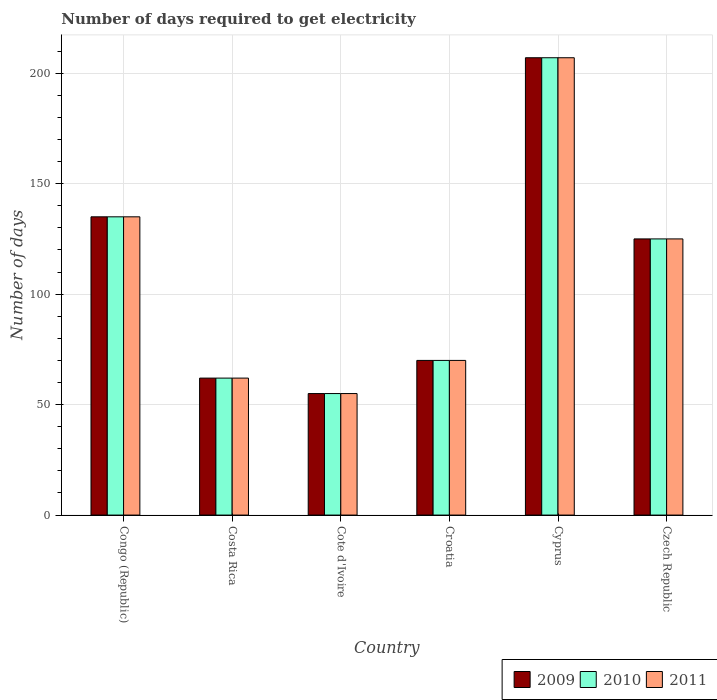Are the number of bars per tick equal to the number of legend labels?
Provide a succinct answer. Yes. Are the number of bars on each tick of the X-axis equal?
Keep it short and to the point. Yes. How many bars are there on the 1st tick from the right?
Provide a succinct answer. 3. What is the label of the 5th group of bars from the left?
Your answer should be very brief. Cyprus. In how many cases, is the number of bars for a given country not equal to the number of legend labels?
Keep it short and to the point. 0. Across all countries, what is the maximum number of days required to get electricity in in 2009?
Provide a succinct answer. 207. Across all countries, what is the minimum number of days required to get electricity in in 2009?
Your answer should be compact. 55. In which country was the number of days required to get electricity in in 2009 maximum?
Provide a succinct answer. Cyprus. In which country was the number of days required to get electricity in in 2010 minimum?
Make the answer very short. Cote d'Ivoire. What is the total number of days required to get electricity in in 2009 in the graph?
Provide a succinct answer. 654. What is the difference between the number of days required to get electricity in in 2011 in Cote d'Ivoire and that in Cyprus?
Your answer should be compact. -152. What is the difference between the number of days required to get electricity in in 2010 in Costa Rica and the number of days required to get electricity in in 2009 in Cyprus?
Offer a terse response. -145. What is the average number of days required to get electricity in in 2010 per country?
Your answer should be very brief. 109. What is the difference between the number of days required to get electricity in of/in 2011 and number of days required to get electricity in of/in 2010 in Croatia?
Provide a succinct answer. 0. In how many countries, is the number of days required to get electricity in in 2010 greater than 140 days?
Your answer should be very brief. 1. What is the ratio of the number of days required to get electricity in in 2009 in Costa Rica to that in Cyprus?
Your answer should be compact. 0.3. What is the difference between the highest and the lowest number of days required to get electricity in in 2011?
Offer a very short reply. 152. Is the sum of the number of days required to get electricity in in 2011 in Costa Rica and Cote d'Ivoire greater than the maximum number of days required to get electricity in in 2010 across all countries?
Give a very brief answer. No. Are all the bars in the graph horizontal?
Offer a terse response. No. Are the values on the major ticks of Y-axis written in scientific E-notation?
Provide a succinct answer. No. Does the graph contain grids?
Ensure brevity in your answer.  Yes. How many legend labels are there?
Your response must be concise. 3. How are the legend labels stacked?
Give a very brief answer. Horizontal. What is the title of the graph?
Give a very brief answer. Number of days required to get electricity. What is the label or title of the X-axis?
Provide a short and direct response. Country. What is the label or title of the Y-axis?
Give a very brief answer. Number of days. What is the Number of days of 2009 in Congo (Republic)?
Your answer should be very brief. 135. What is the Number of days in 2010 in Congo (Republic)?
Ensure brevity in your answer.  135. What is the Number of days of 2011 in Congo (Republic)?
Make the answer very short. 135. What is the Number of days of 2009 in Costa Rica?
Your response must be concise. 62. What is the Number of days in 2009 in Croatia?
Offer a terse response. 70. What is the Number of days of 2010 in Croatia?
Your answer should be compact. 70. What is the Number of days of 2009 in Cyprus?
Your answer should be compact. 207. What is the Number of days of 2010 in Cyprus?
Your response must be concise. 207. What is the Number of days in 2011 in Cyprus?
Provide a succinct answer. 207. What is the Number of days in 2009 in Czech Republic?
Your answer should be compact. 125. What is the Number of days of 2010 in Czech Republic?
Provide a succinct answer. 125. What is the Number of days of 2011 in Czech Republic?
Offer a terse response. 125. Across all countries, what is the maximum Number of days of 2009?
Your response must be concise. 207. Across all countries, what is the maximum Number of days in 2010?
Your answer should be very brief. 207. Across all countries, what is the maximum Number of days in 2011?
Your answer should be very brief. 207. Across all countries, what is the minimum Number of days of 2009?
Make the answer very short. 55. Across all countries, what is the minimum Number of days of 2010?
Make the answer very short. 55. Across all countries, what is the minimum Number of days of 2011?
Provide a succinct answer. 55. What is the total Number of days in 2009 in the graph?
Provide a succinct answer. 654. What is the total Number of days of 2010 in the graph?
Ensure brevity in your answer.  654. What is the total Number of days of 2011 in the graph?
Provide a short and direct response. 654. What is the difference between the Number of days of 2010 in Congo (Republic) and that in Costa Rica?
Offer a terse response. 73. What is the difference between the Number of days in 2011 in Congo (Republic) and that in Cote d'Ivoire?
Make the answer very short. 80. What is the difference between the Number of days of 2009 in Congo (Republic) and that in Croatia?
Give a very brief answer. 65. What is the difference between the Number of days of 2011 in Congo (Republic) and that in Croatia?
Make the answer very short. 65. What is the difference between the Number of days in 2009 in Congo (Republic) and that in Cyprus?
Give a very brief answer. -72. What is the difference between the Number of days of 2010 in Congo (Republic) and that in Cyprus?
Provide a short and direct response. -72. What is the difference between the Number of days in 2011 in Congo (Republic) and that in Cyprus?
Provide a short and direct response. -72. What is the difference between the Number of days in 2010 in Costa Rica and that in Cote d'Ivoire?
Your answer should be compact. 7. What is the difference between the Number of days in 2011 in Costa Rica and that in Cote d'Ivoire?
Provide a short and direct response. 7. What is the difference between the Number of days of 2009 in Costa Rica and that in Croatia?
Keep it short and to the point. -8. What is the difference between the Number of days in 2011 in Costa Rica and that in Croatia?
Your response must be concise. -8. What is the difference between the Number of days in 2009 in Costa Rica and that in Cyprus?
Keep it short and to the point. -145. What is the difference between the Number of days of 2010 in Costa Rica and that in Cyprus?
Give a very brief answer. -145. What is the difference between the Number of days in 2011 in Costa Rica and that in Cyprus?
Offer a terse response. -145. What is the difference between the Number of days of 2009 in Costa Rica and that in Czech Republic?
Give a very brief answer. -63. What is the difference between the Number of days in 2010 in Costa Rica and that in Czech Republic?
Keep it short and to the point. -63. What is the difference between the Number of days in 2011 in Costa Rica and that in Czech Republic?
Your response must be concise. -63. What is the difference between the Number of days of 2010 in Cote d'Ivoire and that in Croatia?
Ensure brevity in your answer.  -15. What is the difference between the Number of days in 2009 in Cote d'Ivoire and that in Cyprus?
Keep it short and to the point. -152. What is the difference between the Number of days in 2010 in Cote d'Ivoire and that in Cyprus?
Your answer should be compact. -152. What is the difference between the Number of days of 2011 in Cote d'Ivoire and that in Cyprus?
Offer a terse response. -152. What is the difference between the Number of days in 2009 in Cote d'Ivoire and that in Czech Republic?
Make the answer very short. -70. What is the difference between the Number of days of 2010 in Cote d'Ivoire and that in Czech Republic?
Provide a succinct answer. -70. What is the difference between the Number of days in 2011 in Cote d'Ivoire and that in Czech Republic?
Give a very brief answer. -70. What is the difference between the Number of days in 2009 in Croatia and that in Cyprus?
Provide a short and direct response. -137. What is the difference between the Number of days in 2010 in Croatia and that in Cyprus?
Keep it short and to the point. -137. What is the difference between the Number of days in 2011 in Croatia and that in Cyprus?
Your answer should be very brief. -137. What is the difference between the Number of days of 2009 in Croatia and that in Czech Republic?
Your response must be concise. -55. What is the difference between the Number of days of 2010 in Croatia and that in Czech Republic?
Offer a very short reply. -55. What is the difference between the Number of days of 2011 in Croatia and that in Czech Republic?
Offer a very short reply. -55. What is the difference between the Number of days of 2009 in Cyprus and that in Czech Republic?
Your response must be concise. 82. What is the difference between the Number of days in 2010 in Cyprus and that in Czech Republic?
Provide a short and direct response. 82. What is the difference between the Number of days in 2010 in Congo (Republic) and the Number of days in 2011 in Costa Rica?
Your response must be concise. 73. What is the difference between the Number of days in 2009 in Congo (Republic) and the Number of days in 2010 in Cote d'Ivoire?
Offer a very short reply. 80. What is the difference between the Number of days of 2009 in Congo (Republic) and the Number of days of 2011 in Cote d'Ivoire?
Your answer should be compact. 80. What is the difference between the Number of days in 2010 in Congo (Republic) and the Number of days in 2011 in Cote d'Ivoire?
Your answer should be compact. 80. What is the difference between the Number of days in 2009 in Congo (Republic) and the Number of days in 2011 in Croatia?
Your response must be concise. 65. What is the difference between the Number of days in 2009 in Congo (Republic) and the Number of days in 2010 in Cyprus?
Your answer should be very brief. -72. What is the difference between the Number of days in 2009 in Congo (Republic) and the Number of days in 2011 in Cyprus?
Make the answer very short. -72. What is the difference between the Number of days of 2010 in Congo (Republic) and the Number of days of 2011 in Cyprus?
Your answer should be very brief. -72. What is the difference between the Number of days in 2009 in Congo (Republic) and the Number of days in 2010 in Czech Republic?
Keep it short and to the point. 10. What is the difference between the Number of days in 2010 in Congo (Republic) and the Number of days in 2011 in Czech Republic?
Provide a short and direct response. 10. What is the difference between the Number of days of 2009 in Costa Rica and the Number of days of 2010 in Cote d'Ivoire?
Your answer should be very brief. 7. What is the difference between the Number of days in 2010 in Costa Rica and the Number of days in 2011 in Cote d'Ivoire?
Offer a terse response. 7. What is the difference between the Number of days in 2010 in Costa Rica and the Number of days in 2011 in Croatia?
Provide a short and direct response. -8. What is the difference between the Number of days of 2009 in Costa Rica and the Number of days of 2010 in Cyprus?
Your answer should be very brief. -145. What is the difference between the Number of days of 2009 in Costa Rica and the Number of days of 2011 in Cyprus?
Offer a terse response. -145. What is the difference between the Number of days in 2010 in Costa Rica and the Number of days in 2011 in Cyprus?
Provide a succinct answer. -145. What is the difference between the Number of days of 2009 in Costa Rica and the Number of days of 2010 in Czech Republic?
Provide a succinct answer. -63. What is the difference between the Number of days in 2009 in Costa Rica and the Number of days in 2011 in Czech Republic?
Your response must be concise. -63. What is the difference between the Number of days in 2010 in Costa Rica and the Number of days in 2011 in Czech Republic?
Give a very brief answer. -63. What is the difference between the Number of days in 2010 in Cote d'Ivoire and the Number of days in 2011 in Croatia?
Ensure brevity in your answer.  -15. What is the difference between the Number of days in 2009 in Cote d'Ivoire and the Number of days in 2010 in Cyprus?
Give a very brief answer. -152. What is the difference between the Number of days of 2009 in Cote d'Ivoire and the Number of days of 2011 in Cyprus?
Give a very brief answer. -152. What is the difference between the Number of days in 2010 in Cote d'Ivoire and the Number of days in 2011 in Cyprus?
Keep it short and to the point. -152. What is the difference between the Number of days in 2009 in Cote d'Ivoire and the Number of days in 2010 in Czech Republic?
Ensure brevity in your answer.  -70. What is the difference between the Number of days of 2009 in Cote d'Ivoire and the Number of days of 2011 in Czech Republic?
Keep it short and to the point. -70. What is the difference between the Number of days of 2010 in Cote d'Ivoire and the Number of days of 2011 in Czech Republic?
Give a very brief answer. -70. What is the difference between the Number of days of 2009 in Croatia and the Number of days of 2010 in Cyprus?
Keep it short and to the point. -137. What is the difference between the Number of days in 2009 in Croatia and the Number of days in 2011 in Cyprus?
Give a very brief answer. -137. What is the difference between the Number of days of 2010 in Croatia and the Number of days of 2011 in Cyprus?
Give a very brief answer. -137. What is the difference between the Number of days of 2009 in Croatia and the Number of days of 2010 in Czech Republic?
Offer a very short reply. -55. What is the difference between the Number of days in 2009 in Croatia and the Number of days in 2011 in Czech Republic?
Your response must be concise. -55. What is the difference between the Number of days of 2010 in Croatia and the Number of days of 2011 in Czech Republic?
Your answer should be compact. -55. What is the difference between the Number of days of 2009 in Cyprus and the Number of days of 2011 in Czech Republic?
Your answer should be very brief. 82. What is the difference between the Number of days of 2010 in Cyprus and the Number of days of 2011 in Czech Republic?
Give a very brief answer. 82. What is the average Number of days in 2009 per country?
Your answer should be very brief. 109. What is the average Number of days of 2010 per country?
Make the answer very short. 109. What is the average Number of days in 2011 per country?
Ensure brevity in your answer.  109. What is the difference between the Number of days in 2009 and Number of days in 2010 in Congo (Republic)?
Offer a very short reply. 0. What is the difference between the Number of days in 2009 and Number of days in 2011 in Congo (Republic)?
Ensure brevity in your answer.  0. What is the difference between the Number of days in 2010 and Number of days in 2011 in Congo (Republic)?
Give a very brief answer. 0. What is the difference between the Number of days in 2009 and Number of days in 2010 in Costa Rica?
Ensure brevity in your answer.  0. What is the difference between the Number of days in 2009 and Number of days in 2011 in Costa Rica?
Keep it short and to the point. 0. What is the difference between the Number of days in 2010 and Number of days in 2011 in Costa Rica?
Give a very brief answer. 0. What is the difference between the Number of days in 2009 and Number of days in 2010 in Cote d'Ivoire?
Your answer should be compact. 0. What is the difference between the Number of days of 2010 and Number of days of 2011 in Cote d'Ivoire?
Make the answer very short. 0. What is the difference between the Number of days of 2009 and Number of days of 2011 in Croatia?
Provide a succinct answer. 0. What is the difference between the Number of days in 2010 and Number of days in 2011 in Croatia?
Make the answer very short. 0. What is the difference between the Number of days in 2009 and Number of days in 2010 in Cyprus?
Your answer should be very brief. 0. What is the difference between the Number of days in 2009 and Number of days in 2010 in Czech Republic?
Your answer should be very brief. 0. What is the difference between the Number of days in 2009 and Number of days in 2011 in Czech Republic?
Ensure brevity in your answer.  0. What is the ratio of the Number of days of 2009 in Congo (Republic) to that in Costa Rica?
Offer a very short reply. 2.18. What is the ratio of the Number of days of 2010 in Congo (Republic) to that in Costa Rica?
Your answer should be very brief. 2.18. What is the ratio of the Number of days of 2011 in Congo (Republic) to that in Costa Rica?
Make the answer very short. 2.18. What is the ratio of the Number of days of 2009 in Congo (Republic) to that in Cote d'Ivoire?
Keep it short and to the point. 2.45. What is the ratio of the Number of days in 2010 in Congo (Republic) to that in Cote d'Ivoire?
Offer a terse response. 2.45. What is the ratio of the Number of days in 2011 in Congo (Republic) to that in Cote d'Ivoire?
Provide a short and direct response. 2.45. What is the ratio of the Number of days in 2009 in Congo (Republic) to that in Croatia?
Give a very brief answer. 1.93. What is the ratio of the Number of days in 2010 in Congo (Republic) to that in Croatia?
Provide a short and direct response. 1.93. What is the ratio of the Number of days of 2011 in Congo (Republic) to that in Croatia?
Keep it short and to the point. 1.93. What is the ratio of the Number of days in 2009 in Congo (Republic) to that in Cyprus?
Provide a succinct answer. 0.65. What is the ratio of the Number of days of 2010 in Congo (Republic) to that in Cyprus?
Your answer should be very brief. 0.65. What is the ratio of the Number of days in 2011 in Congo (Republic) to that in Cyprus?
Keep it short and to the point. 0.65. What is the ratio of the Number of days of 2010 in Congo (Republic) to that in Czech Republic?
Offer a terse response. 1.08. What is the ratio of the Number of days in 2011 in Congo (Republic) to that in Czech Republic?
Provide a short and direct response. 1.08. What is the ratio of the Number of days of 2009 in Costa Rica to that in Cote d'Ivoire?
Provide a short and direct response. 1.13. What is the ratio of the Number of days in 2010 in Costa Rica to that in Cote d'Ivoire?
Provide a succinct answer. 1.13. What is the ratio of the Number of days in 2011 in Costa Rica to that in Cote d'Ivoire?
Your answer should be very brief. 1.13. What is the ratio of the Number of days in 2009 in Costa Rica to that in Croatia?
Ensure brevity in your answer.  0.89. What is the ratio of the Number of days of 2010 in Costa Rica to that in Croatia?
Provide a short and direct response. 0.89. What is the ratio of the Number of days in 2011 in Costa Rica to that in Croatia?
Give a very brief answer. 0.89. What is the ratio of the Number of days in 2009 in Costa Rica to that in Cyprus?
Make the answer very short. 0.3. What is the ratio of the Number of days of 2010 in Costa Rica to that in Cyprus?
Give a very brief answer. 0.3. What is the ratio of the Number of days in 2011 in Costa Rica to that in Cyprus?
Your answer should be very brief. 0.3. What is the ratio of the Number of days of 2009 in Costa Rica to that in Czech Republic?
Ensure brevity in your answer.  0.5. What is the ratio of the Number of days of 2010 in Costa Rica to that in Czech Republic?
Provide a succinct answer. 0.5. What is the ratio of the Number of days in 2011 in Costa Rica to that in Czech Republic?
Make the answer very short. 0.5. What is the ratio of the Number of days of 2009 in Cote d'Ivoire to that in Croatia?
Make the answer very short. 0.79. What is the ratio of the Number of days of 2010 in Cote d'Ivoire to that in Croatia?
Provide a succinct answer. 0.79. What is the ratio of the Number of days of 2011 in Cote d'Ivoire to that in Croatia?
Provide a succinct answer. 0.79. What is the ratio of the Number of days in 2009 in Cote d'Ivoire to that in Cyprus?
Your answer should be very brief. 0.27. What is the ratio of the Number of days in 2010 in Cote d'Ivoire to that in Cyprus?
Offer a very short reply. 0.27. What is the ratio of the Number of days of 2011 in Cote d'Ivoire to that in Cyprus?
Offer a very short reply. 0.27. What is the ratio of the Number of days in 2009 in Cote d'Ivoire to that in Czech Republic?
Give a very brief answer. 0.44. What is the ratio of the Number of days in 2010 in Cote d'Ivoire to that in Czech Republic?
Ensure brevity in your answer.  0.44. What is the ratio of the Number of days of 2011 in Cote d'Ivoire to that in Czech Republic?
Offer a terse response. 0.44. What is the ratio of the Number of days in 2009 in Croatia to that in Cyprus?
Offer a very short reply. 0.34. What is the ratio of the Number of days of 2010 in Croatia to that in Cyprus?
Offer a very short reply. 0.34. What is the ratio of the Number of days of 2011 in Croatia to that in Cyprus?
Your response must be concise. 0.34. What is the ratio of the Number of days of 2009 in Croatia to that in Czech Republic?
Ensure brevity in your answer.  0.56. What is the ratio of the Number of days in 2010 in Croatia to that in Czech Republic?
Keep it short and to the point. 0.56. What is the ratio of the Number of days in 2011 in Croatia to that in Czech Republic?
Make the answer very short. 0.56. What is the ratio of the Number of days of 2009 in Cyprus to that in Czech Republic?
Give a very brief answer. 1.66. What is the ratio of the Number of days of 2010 in Cyprus to that in Czech Republic?
Provide a short and direct response. 1.66. What is the ratio of the Number of days of 2011 in Cyprus to that in Czech Republic?
Offer a terse response. 1.66. What is the difference between the highest and the second highest Number of days in 2009?
Your answer should be very brief. 72. What is the difference between the highest and the second highest Number of days of 2011?
Make the answer very short. 72. What is the difference between the highest and the lowest Number of days in 2009?
Make the answer very short. 152. What is the difference between the highest and the lowest Number of days in 2010?
Your answer should be compact. 152. What is the difference between the highest and the lowest Number of days of 2011?
Make the answer very short. 152. 